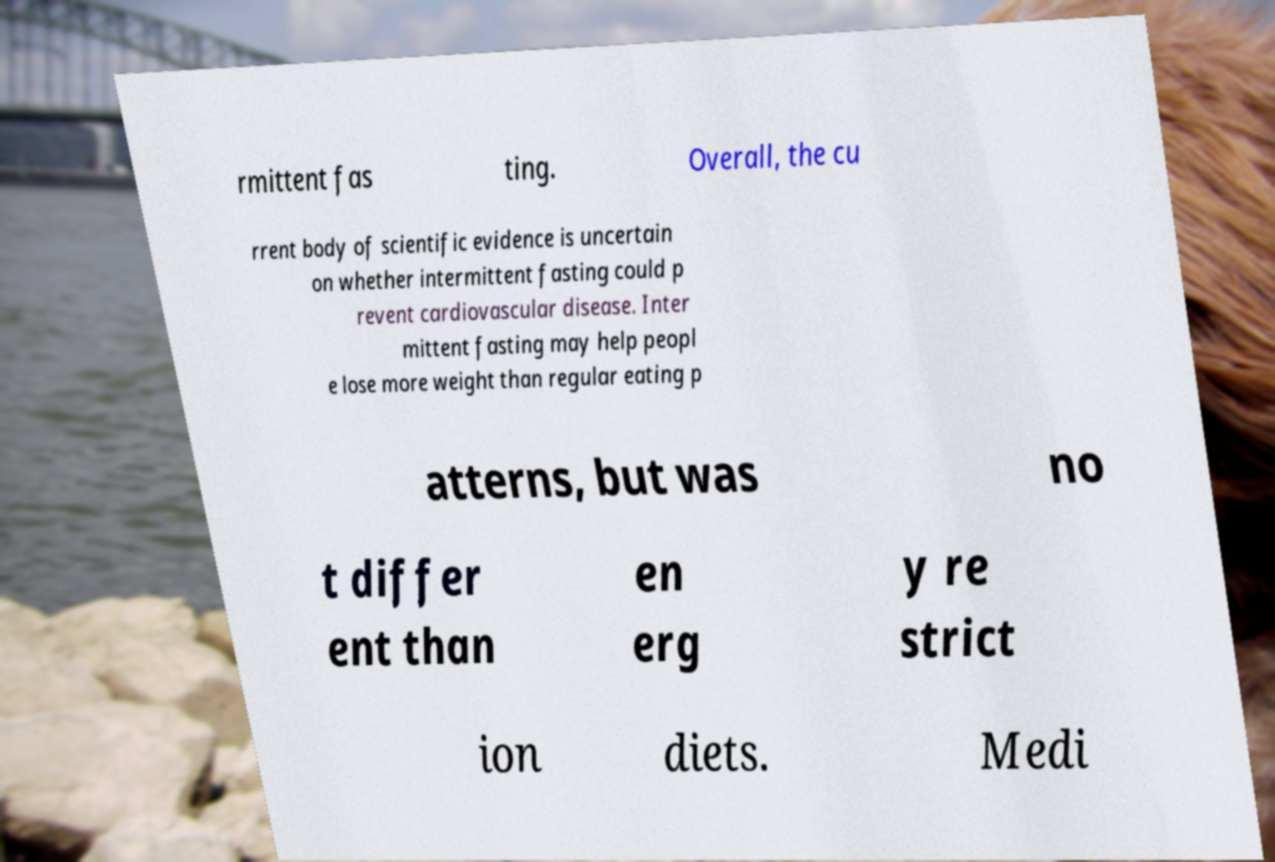Can you read and provide the text displayed in the image?This photo seems to have some interesting text. Can you extract and type it out for me? rmittent fas ting. Overall, the cu rrent body of scientific evidence is uncertain on whether intermittent fasting could p revent cardiovascular disease. Inter mittent fasting may help peopl e lose more weight than regular eating p atterns, but was no t differ ent than en erg y re strict ion diets. Medi 